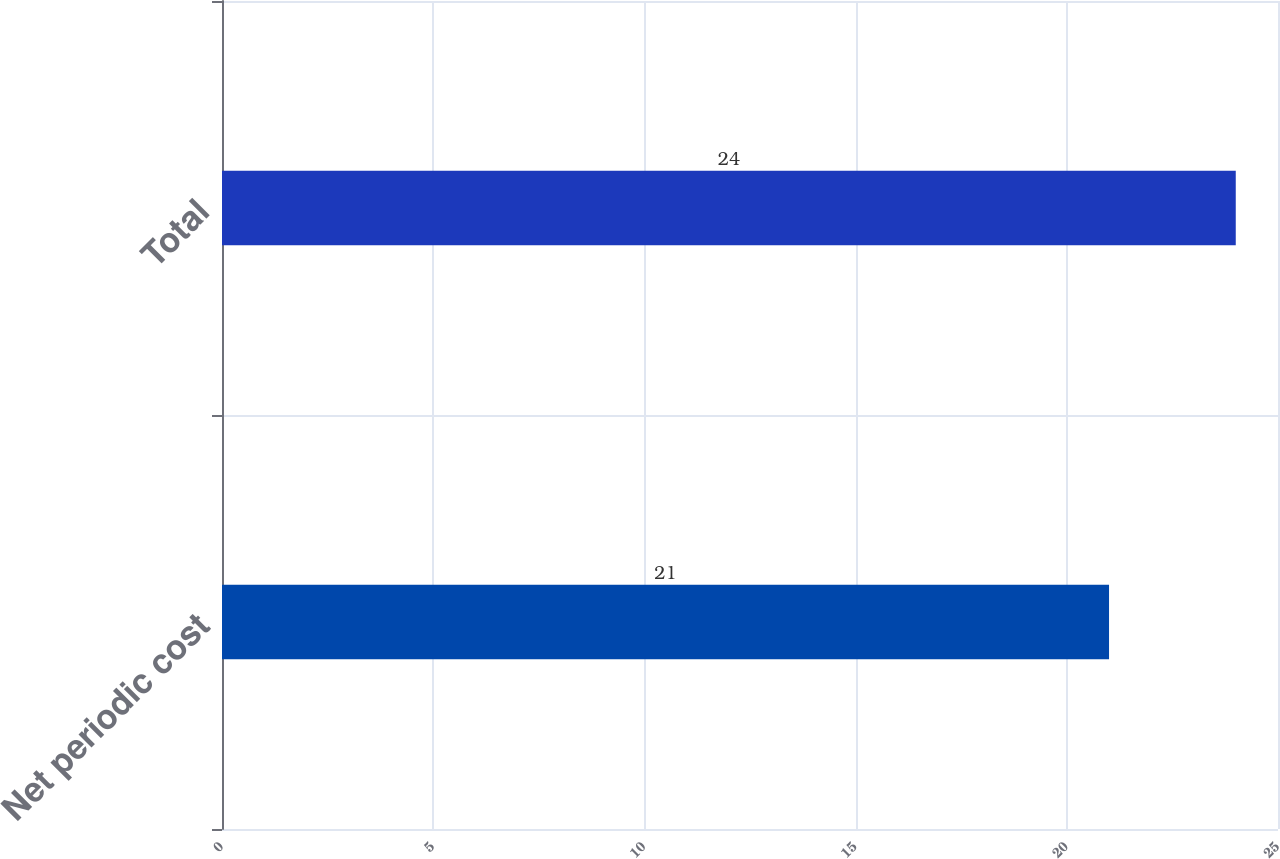<chart> <loc_0><loc_0><loc_500><loc_500><bar_chart><fcel>Net periodic cost<fcel>Total<nl><fcel>21<fcel>24<nl></chart> 